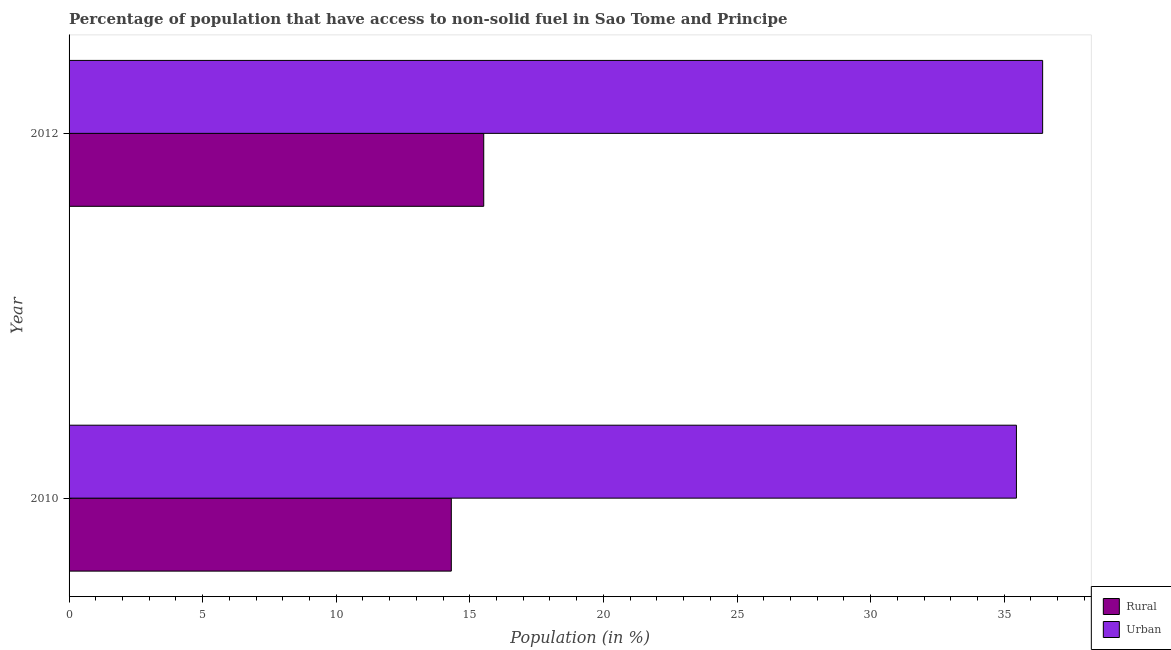How many groups of bars are there?
Give a very brief answer. 2. Are the number of bars per tick equal to the number of legend labels?
Your response must be concise. Yes. How many bars are there on the 1st tick from the top?
Provide a short and direct response. 2. How many bars are there on the 1st tick from the bottom?
Your answer should be compact. 2. What is the urban population in 2012?
Ensure brevity in your answer.  36.44. Across all years, what is the maximum urban population?
Your answer should be very brief. 36.44. Across all years, what is the minimum urban population?
Offer a very short reply. 35.46. In which year was the urban population maximum?
Provide a short and direct response. 2012. What is the total rural population in the graph?
Give a very brief answer. 29.83. What is the difference between the rural population in 2010 and that in 2012?
Your response must be concise. -1.21. What is the difference between the urban population in 2010 and the rural population in 2012?
Provide a succinct answer. 19.94. What is the average urban population per year?
Your answer should be very brief. 35.95. In the year 2012, what is the difference between the rural population and urban population?
Give a very brief answer. -20.92. What does the 1st bar from the top in 2010 represents?
Your answer should be very brief. Urban. What does the 1st bar from the bottom in 2010 represents?
Provide a succinct answer. Rural. How many bars are there?
Provide a succinct answer. 4. Are all the bars in the graph horizontal?
Offer a terse response. Yes. What is the difference between two consecutive major ticks on the X-axis?
Give a very brief answer. 5. Does the graph contain any zero values?
Keep it short and to the point. No. Does the graph contain grids?
Your answer should be very brief. No. Where does the legend appear in the graph?
Give a very brief answer. Bottom right. How many legend labels are there?
Provide a succinct answer. 2. What is the title of the graph?
Give a very brief answer. Percentage of population that have access to non-solid fuel in Sao Tome and Principe. Does "Export" appear as one of the legend labels in the graph?
Your answer should be compact. No. What is the Population (in %) of Rural in 2010?
Your answer should be very brief. 14.31. What is the Population (in %) in Urban in 2010?
Offer a terse response. 35.46. What is the Population (in %) of Rural in 2012?
Your answer should be very brief. 15.52. What is the Population (in %) of Urban in 2012?
Keep it short and to the point. 36.44. Across all years, what is the maximum Population (in %) of Rural?
Give a very brief answer. 15.52. Across all years, what is the maximum Population (in %) in Urban?
Offer a very short reply. 36.44. Across all years, what is the minimum Population (in %) of Rural?
Provide a succinct answer. 14.31. Across all years, what is the minimum Population (in %) of Urban?
Provide a short and direct response. 35.46. What is the total Population (in %) of Rural in the graph?
Offer a very short reply. 29.83. What is the total Population (in %) in Urban in the graph?
Your response must be concise. 71.9. What is the difference between the Population (in %) in Rural in 2010 and that in 2012?
Ensure brevity in your answer.  -1.21. What is the difference between the Population (in %) of Urban in 2010 and that in 2012?
Ensure brevity in your answer.  -0.98. What is the difference between the Population (in %) in Rural in 2010 and the Population (in %) in Urban in 2012?
Your answer should be very brief. -22.13. What is the average Population (in %) of Rural per year?
Your answer should be compact. 14.91. What is the average Population (in %) of Urban per year?
Your answer should be compact. 35.95. In the year 2010, what is the difference between the Population (in %) in Rural and Population (in %) in Urban?
Your response must be concise. -21.15. In the year 2012, what is the difference between the Population (in %) of Rural and Population (in %) of Urban?
Your answer should be very brief. -20.92. What is the ratio of the Population (in %) of Rural in 2010 to that in 2012?
Provide a succinct answer. 0.92. What is the ratio of the Population (in %) in Urban in 2010 to that in 2012?
Your answer should be compact. 0.97. What is the difference between the highest and the second highest Population (in %) in Rural?
Ensure brevity in your answer.  1.21. What is the difference between the highest and the second highest Population (in %) of Urban?
Keep it short and to the point. 0.98. What is the difference between the highest and the lowest Population (in %) of Rural?
Offer a very short reply. 1.21. What is the difference between the highest and the lowest Population (in %) of Urban?
Provide a succinct answer. 0.98. 